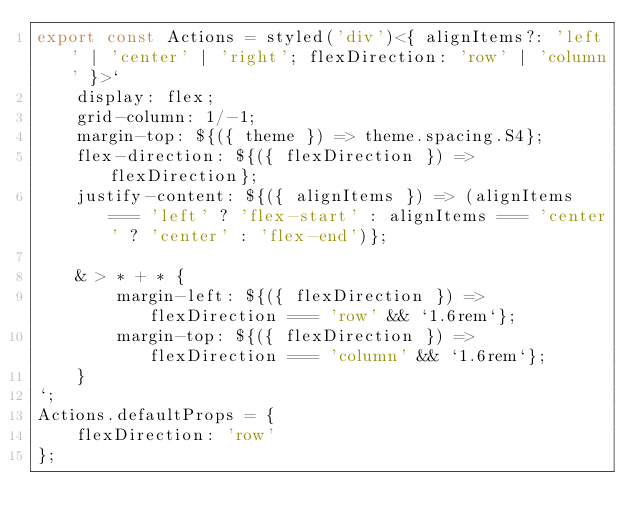<code> <loc_0><loc_0><loc_500><loc_500><_TypeScript_>export const Actions = styled('div')<{ alignItems?: 'left' | 'center' | 'right'; flexDirection: 'row' | 'column' }>`
    display: flex;
    grid-column: 1/-1;
    margin-top: ${({ theme }) => theme.spacing.S4};
    flex-direction: ${({ flexDirection }) => flexDirection};
    justify-content: ${({ alignItems }) => (alignItems === 'left' ? 'flex-start' : alignItems === 'center' ? 'center' : 'flex-end')};

    & > * + * {
        margin-left: ${({ flexDirection }) => flexDirection === 'row' && `1.6rem`};
        margin-top: ${({ flexDirection }) => flexDirection === 'column' && `1.6rem`};
    }
`;
Actions.defaultProps = {
    flexDirection: 'row'
};
</code> 